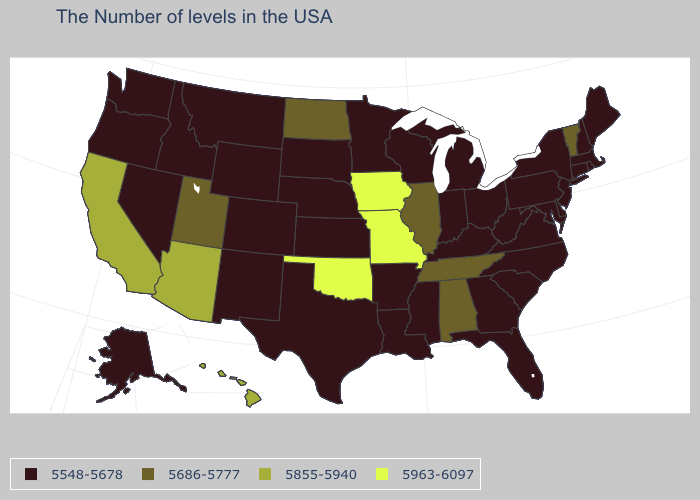Among the states that border Michigan , which have the highest value?
Quick response, please. Ohio, Indiana, Wisconsin. Name the states that have a value in the range 5548-5678?
Give a very brief answer. Maine, Massachusetts, Rhode Island, New Hampshire, Connecticut, New York, New Jersey, Delaware, Maryland, Pennsylvania, Virginia, North Carolina, South Carolina, West Virginia, Ohio, Florida, Georgia, Michigan, Kentucky, Indiana, Wisconsin, Mississippi, Louisiana, Arkansas, Minnesota, Kansas, Nebraska, Texas, South Dakota, Wyoming, Colorado, New Mexico, Montana, Idaho, Nevada, Washington, Oregon, Alaska. What is the value of Vermont?
Give a very brief answer. 5686-5777. How many symbols are there in the legend?
Write a very short answer. 4. What is the lowest value in the USA?
Be succinct. 5548-5678. What is the value of Arizona?
Give a very brief answer. 5855-5940. What is the value of Alaska?
Be succinct. 5548-5678. What is the lowest value in the South?
Short answer required. 5548-5678. What is the value of Kansas?
Be succinct. 5548-5678. Name the states that have a value in the range 5548-5678?
Keep it brief. Maine, Massachusetts, Rhode Island, New Hampshire, Connecticut, New York, New Jersey, Delaware, Maryland, Pennsylvania, Virginia, North Carolina, South Carolina, West Virginia, Ohio, Florida, Georgia, Michigan, Kentucky, Indiana, Wisconsin, Mississippi, Louisiana, Arkansas, Minnesota, Kansas, Nebraska, Texas, South Dakota, Wyoming, Colorado, New Mexico, Montana, Idaho, Nevada, Washington, Oregon, Alaska. What is the lowest value in the South?
Quick response, please. 5548-5678. What is the highest value in states that border Tennessee?
Short answer required. 5963-6097. What is the value of Pennsylvania?
Give a very brief answer. 5548-5678. 